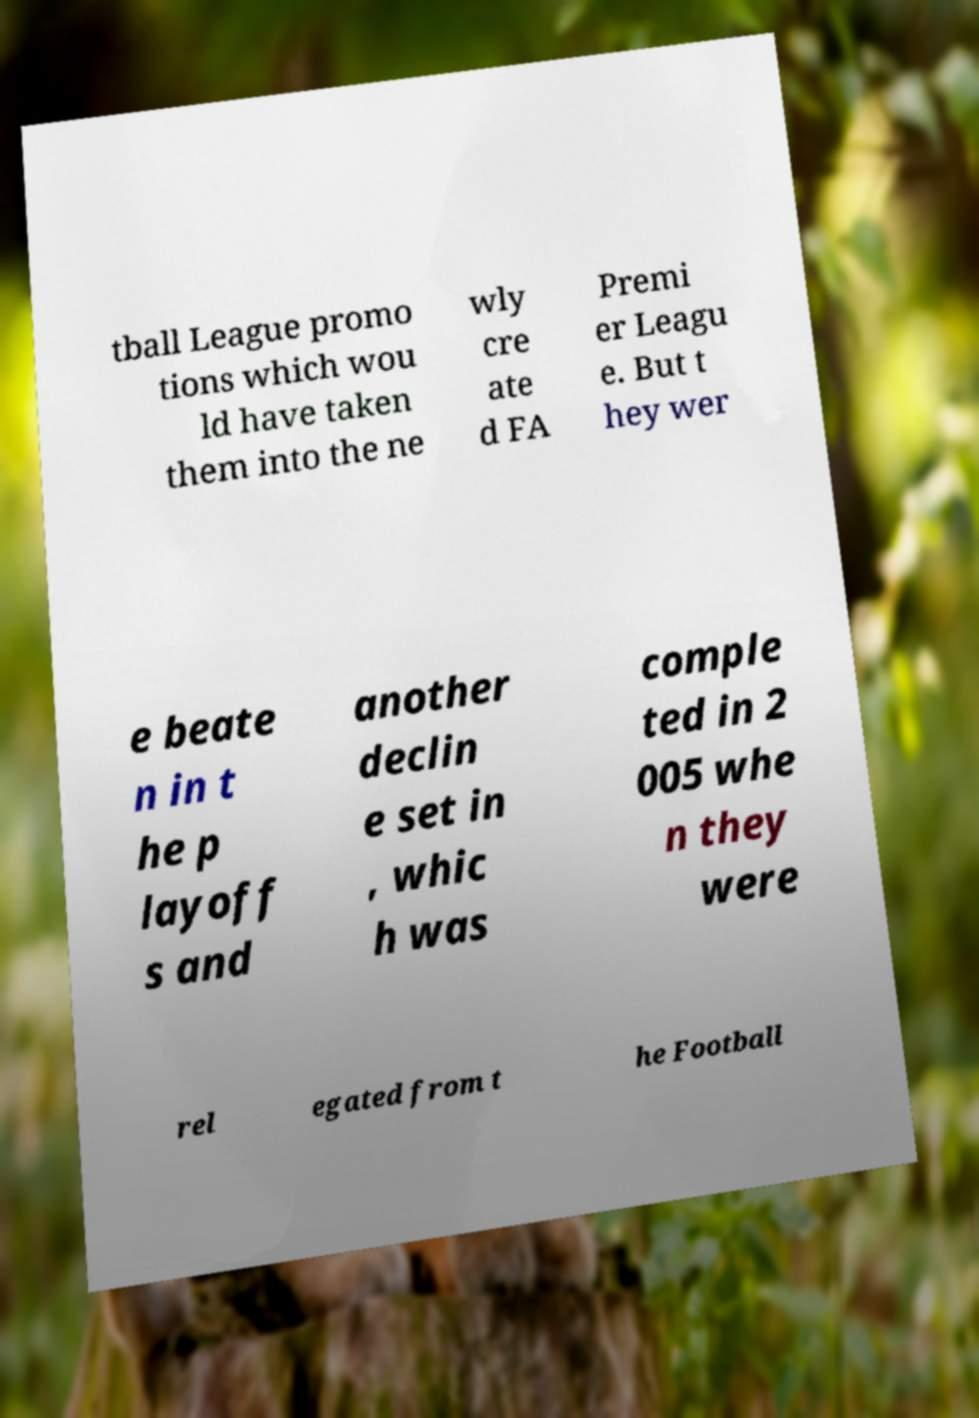What messages or text are displayed in this image? I need them in a readable, typed format. tball League promo tions which wou ld have taken them into the ne wly cre ate d FA Premi er Leagu e. But t hey wer e beate n in t he p layoff s and another declin e set in , whic h was comple ted in 2 005 whe n they were rel egated from t he Football 